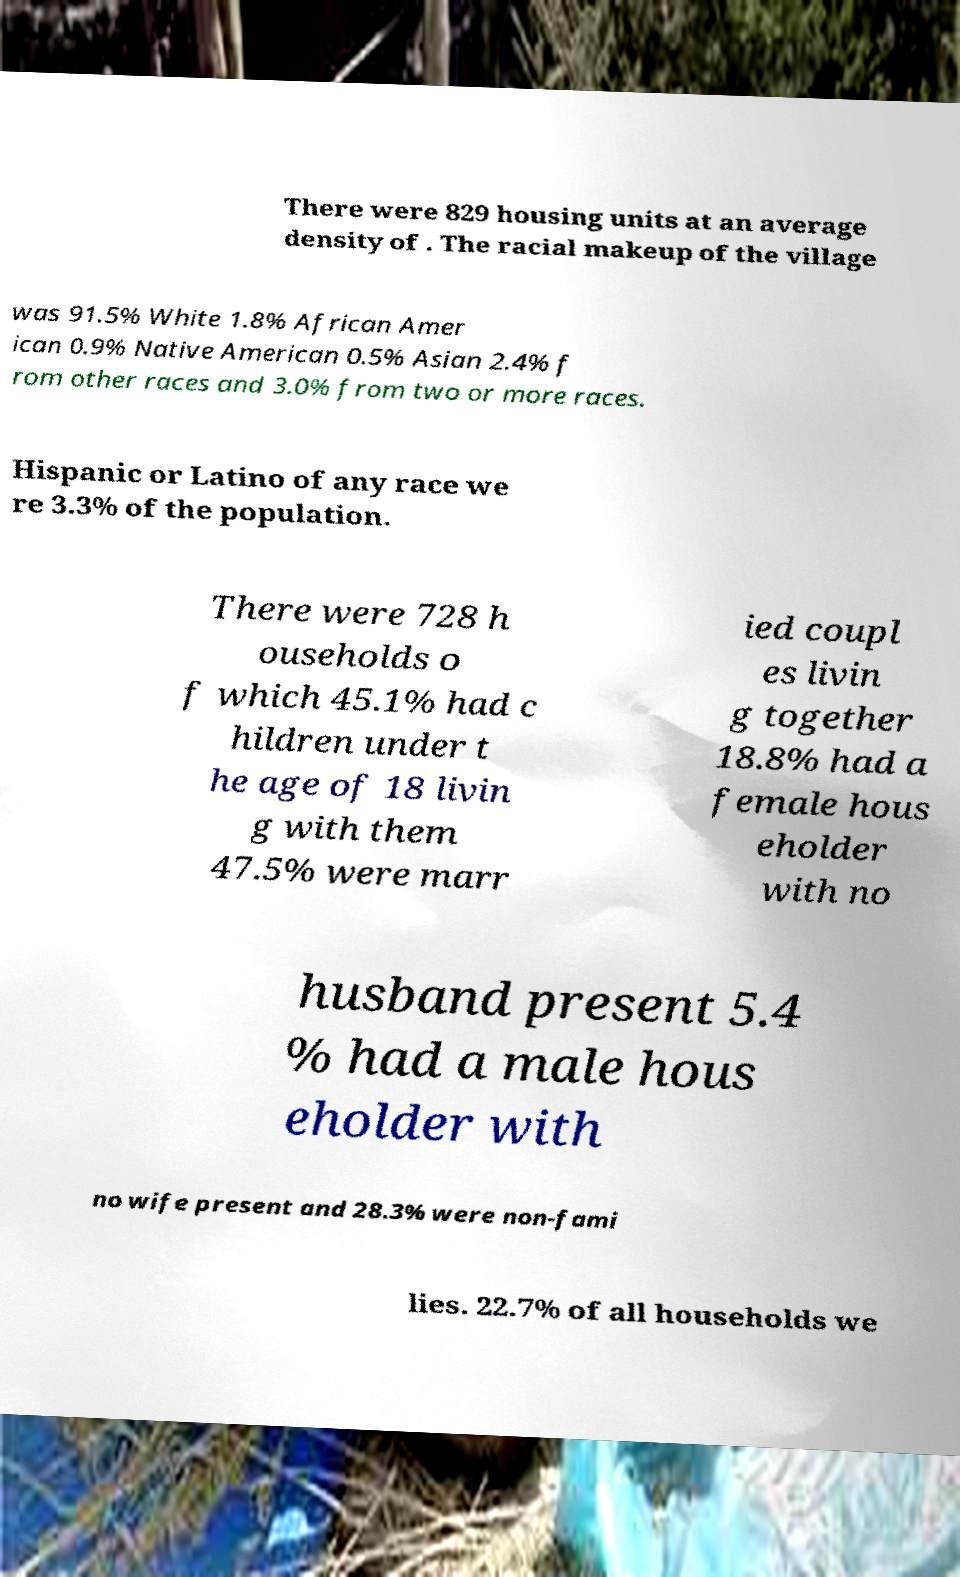Could you assist in decoding the text presented in this image and type it out clearly? There were 829 housing units at an average density of . The racial makeup of the village was 91.5% White 1.8% African Amer ican 0.9% Native American 0.5% Asian 2.4% f rom other races and 3.0% from two or more races. Hispanic or Latino of any race we re 3.3% of the population. There were 728 h ouseholds o f which 45.1% had c hildren under t he age of 18 livin g with them 47.5% were marr ied coupl es livin g together 18.8% had a female hous eholder with no husband present 5.4 % had a male hous eholder with no wife present and 28.3% were non-fami lies. 22.7% of all households we 